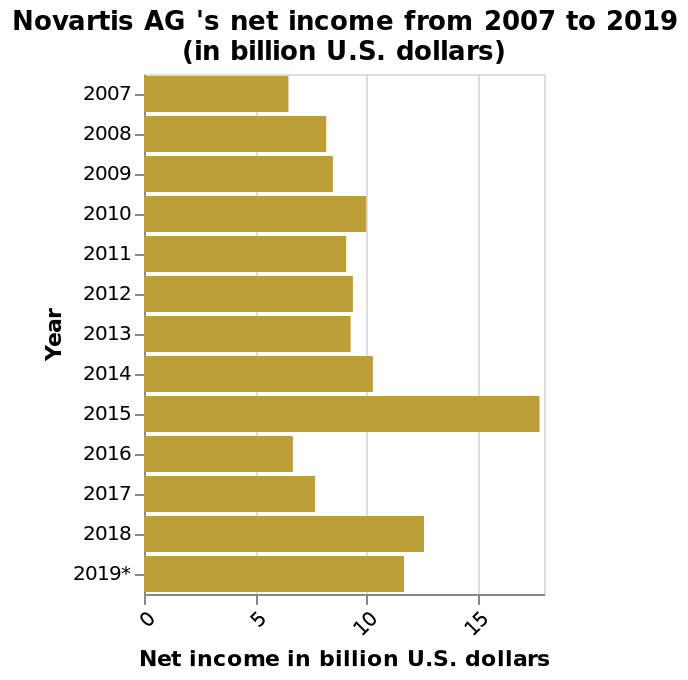<image>
In which year did Novartis achieve the most exceptional income?  Novartis achieved its most exceptional income in the year 2015, with 20 billion US dollars. please summary the statistics and relations of the chart Novartis AG’s most profitable year was 2015, with an over 15 billion dollar net income. Novartis AG’s net income only exceeded 10 billion dollars four times between 2007 and 2019. Novartis AG’s least profitable years were 2007 and 2016. How much income has Novartis consistently achieved each year from 2007 to 2019?  Novartis has consistently achieved incomes in excess of 5 billion dollars each year from 2007 to 2019. How did Novartis' annual profits evolve from 2007 to 2010? Novartis experienced steady growth of annual profits from around 6 billion to 10 billion dollars from 2007 to 2010. Describe the following image in detail Novartis AG 's net income from 2007 to 2019 (in billion U.S. dollars) is a bar plot. The x-axis measures Net income in billion U.S. dollars on linear scale of range 0 to 15 while the y-axis plots Year on categorical scale starting with 2007 and ending with 2019*. Is Novartis AG's net income from 2006 to 2019 (in billion U.S. dollars) represented by a pie chart? No.Novartis AG 's net income from 2007 to 2019 (in billion U.S. dollars) is a bar plot. The x-axis measures Net income in billion U.S. dollars on linear scale of range 0 to 15 while the y-axis plots Year on categorical scale starting with 2007 and ending with 2019*. 